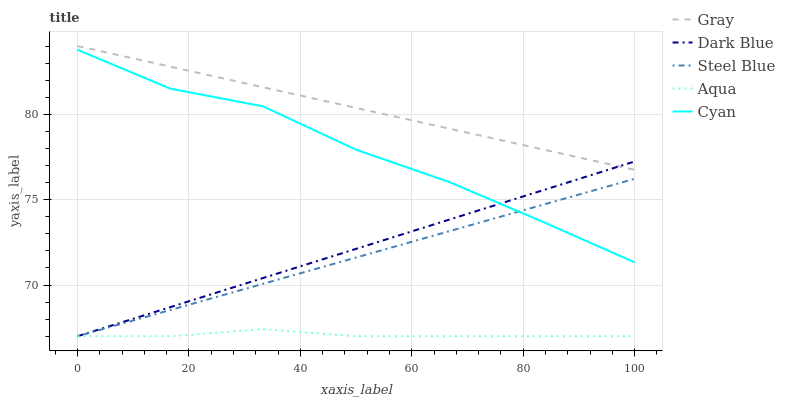Does Aqua have the minimum area under the curve?
Answer yes or no. Yes. Does Gray have the maximum area under the curve?
Answer yes or no. Yes. Does Cyan have the minimum area under the curve?
Answer yes or no. No. Does Cyan have the maximum area under the curve?
Answer yes or no. No. Is Gray the smoothest?
Answer yes or no. Yes. Is Cyan the roughest?
Answer yes or no. Yes. Is Aqua the smoothest?
Answer yes or no. No. Is Aqua the roughest?
Answer yes or no. No. Does Aqua have the lowest value?
Answer yes or no. Yes. Does Cyan have the lowest value?
Answer yes or no. No. Does Gray have the highest value?
Answer yes or no. Yes. Does Cyan have the highest value?
Answer yes or no. No. Is Steel Blue less than Gray?
Answer yes or no. Yes. Is Gray greater than Cyan?
Answer yes or no. Yes. Does Dark Blue intersect Gray?
Answer yes or no. Yes. Is Dark Blue less than Gray?
Answer yes or no. No. Is Dark Blue greater than Gray?
Answer yes or no. No. Does Steel Blue intersect Gray?
Answer yes or no. No. 